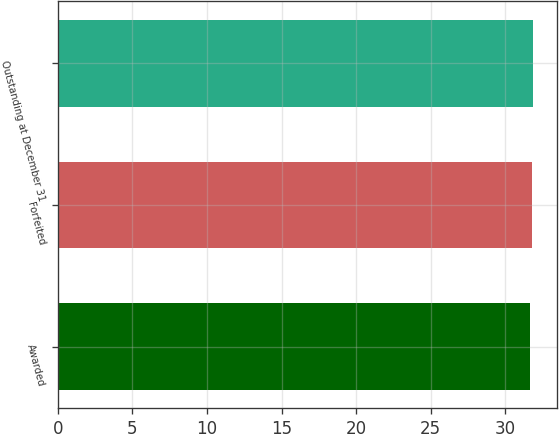<chart> <loc_0><loc_0><loc_500><loc_500><bar_chart><fcel>Awarded<fcel>Forfeited<fcel>Outstanding at December 31<nl><fcel>31.65<fcel>31.75<fcel>31.85<nl></chart> 